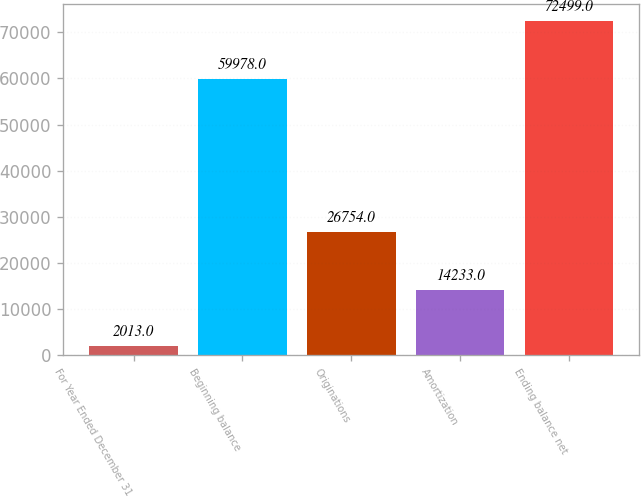Convert chart. <chart><loc_0><loc_0><loc_500><loc_500><bar_chart><fcel>For Year Ended December 31<fcel>Beginning balance<fcel>Originations<fcel>Amortization<fcel>Ending balance net<nl><fcel>2013<fcel>59978<fcel>26754<fcel>14233<fcel>72499<nl></chart> 